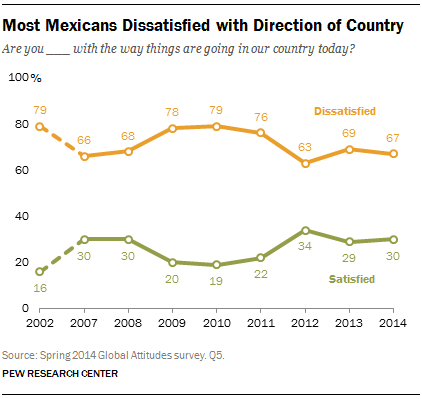Indicate a few pertinent items in this graphic. The missing value is 78, which is not included in the list of numbers 79, 66, 68, 79, 76, 63, 69, 67. There are four values in the green line that are equal to or greater than 30. 